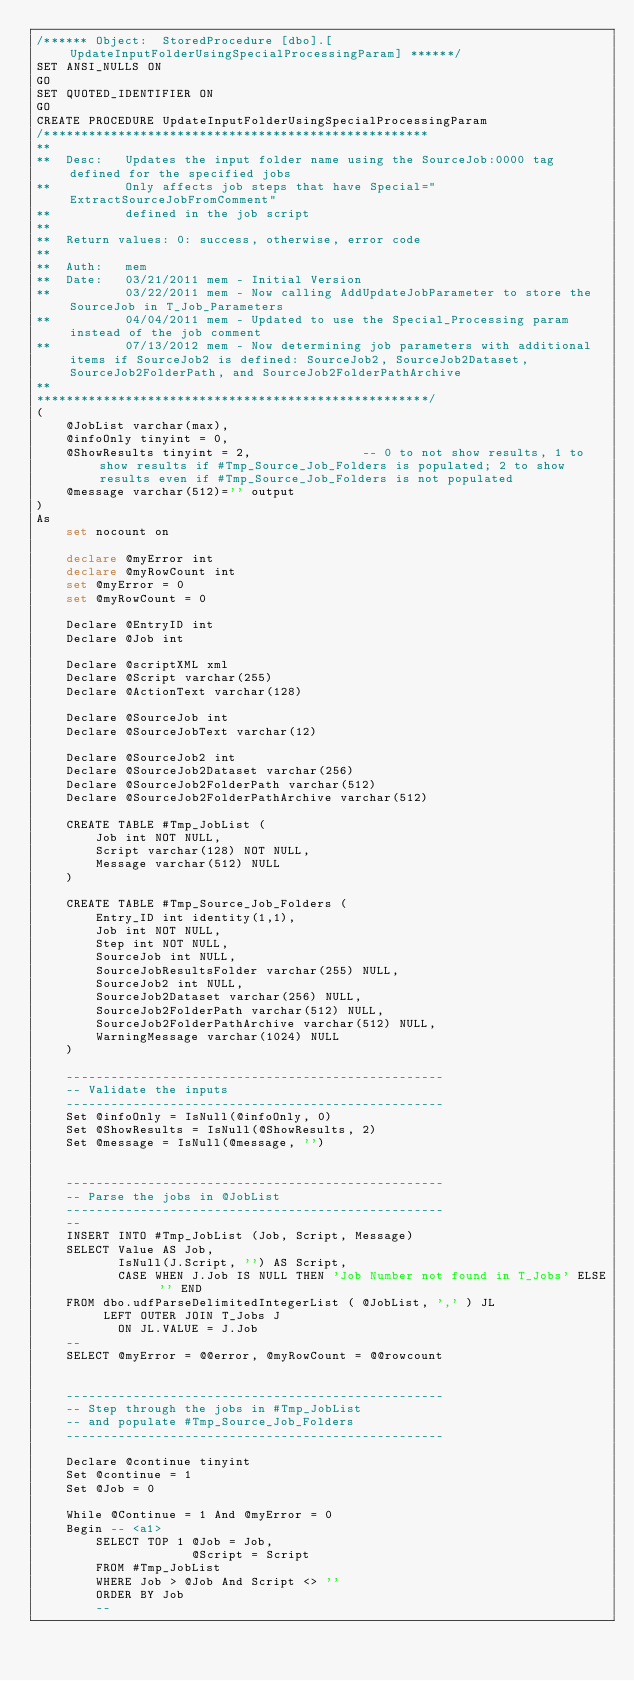Convert code to text. <code><loc_0><loc_0><loc_500><loc_500><_SQL_>/****** Object:  StoredProcedure [dbo].[UpdateInputFolderUsingSpecialProcessingParam] ******/
SET ANSI_NULLS ON
GO
SET QUOTED_IDENTIFIER ON
GO
CREATE PROCEDURE UpdateInputFolderUsingSpecialProcessingParam
/****************************************************
**
**	Desc:	Updates the input folder name using the SourceJob:0000 tag defined for the specified jobs
**			Only affects job steps that have Special="ExtractSourceJobFromComment"
**			defined in the job script
**	
**	Return values: 0: success, otherwise, error code
**
**	Auth:	mem
**	Date:	03/21/2011 mem - Initial Version
**			03/22/2011 mem - Now calling AddUpdateJobParameter to store the SourceJob in T_Job_Parameters
**			04/04/2011 mem - Updated to use the Special_Processing param instead of the job comment
**			07/13/2012 mem - Now determining job parameters with additional items if SourceJob2 is defined: SourceJob2, SourceJob2Dataset, SourceJob2FolderPath, and SourceJob2FolderPathArchive
**    
*****************************************************/
(
	@JobList varchar(max),
	@infoOnly tinyint = 0,
	@ShowResults tinyint = 2,				-- 0 to not show results, 1 to show results if #Tmp_Source_Job_Folders is populated; 2 to show results even if #Tmp_Source_Job_Folders is not populated
	@message varchar(512)='' output
)
As
	set nocount on
	
	declare @myError int
	declare @myRowCount int
	set @myError = 0
	set @myRowCount = 0
	
	Declare @EntryID int
	Declare @Job int
	
	Declare @scriptXML xml
	Declare @Script varchar(255)
	Declare @ActionText varchar(128)

	Declare @SourceJob int
	Declare @SourceJobText varchar(12)

	Declare @SourceJob2 int
	Declare @SourceJob2Dataset varchar(256)
	Declare @SourceJob2FolderPath varchar(512)
	Declare @SourceJob2FolderPathArchive varchar(512)
	
	CREATE TABLE #Tmp_JobList (
		Job int NOT NULL,
		Script varchar(128) NOT NULL,
		Message varchar(512) NULL
	)
	
	CREATE TABLE #Tmp_Source_Job_Folders (
		Entry_ID int identity(1,1),
		Job int NOT NULL,
		Step int NOT NULL,
		SourceJob int NULL,
		SourceJobResultsFolder varchar(255) NULL,
		SourceJob2 int NULL,
		SourceJob2Dataset varchar(256) NULL,
		SourceJob2FolderPath varchar(512) NULL,
		SourceJob2FolderPathArchive varchar(512) NULL,
		WarningMessage varchar(1024) NULL
	)

	---------------------------------------------------
	-- Validate the inputs
	---------------------------------------------------
	Set @infoOnly = IsNull(@infoOnly, 0)
	Set @ShowResults = IsNull(@ShowResults, 2)
	Set @message = IsNull(@message, '')


	---------------------------------------------------
	-- Parse the jobs in @JobList
	---------------------------------------------------
	--
	INSERT INTO #Tmp_JobList (Job, Script, Message)
	SELECT Value AS Job,
	       IsNull(J.Script, '') AS Script,
	       CASE WHEN J.Job IS NULL THEN 'Job Number not found in T_Jobs' ELSE '' END
	FROM dbo.udfParseDelimitedIntegerList ( @JobList, ',' ) JL
	     LEFT OUTER JOIN T_Jobs J
	       ON JL.VALUE = J.Job
	--
	SELECT @myError = @@error, @myRowCount = @@rowcount
	
	
	---------------------------------------------------
	-- Step through the jobs in #Tmp_JobList
	-- and populate #Tmp_Source_Job_Folders
	---------------------------------------------------
	
	Declare @continue tinyint
	Set @continue = 1
	Set @Job = 0
	
	While @Continue = 1 And @myError = 0
	Begin -- <a1>
		SELECT TOP 1 @Job = Job,
		             @Script = Script
		FROM #Tmp_JobList
		WHERE Job > @Job And Script <> ''
		ORDER BY Job
		--</code> 